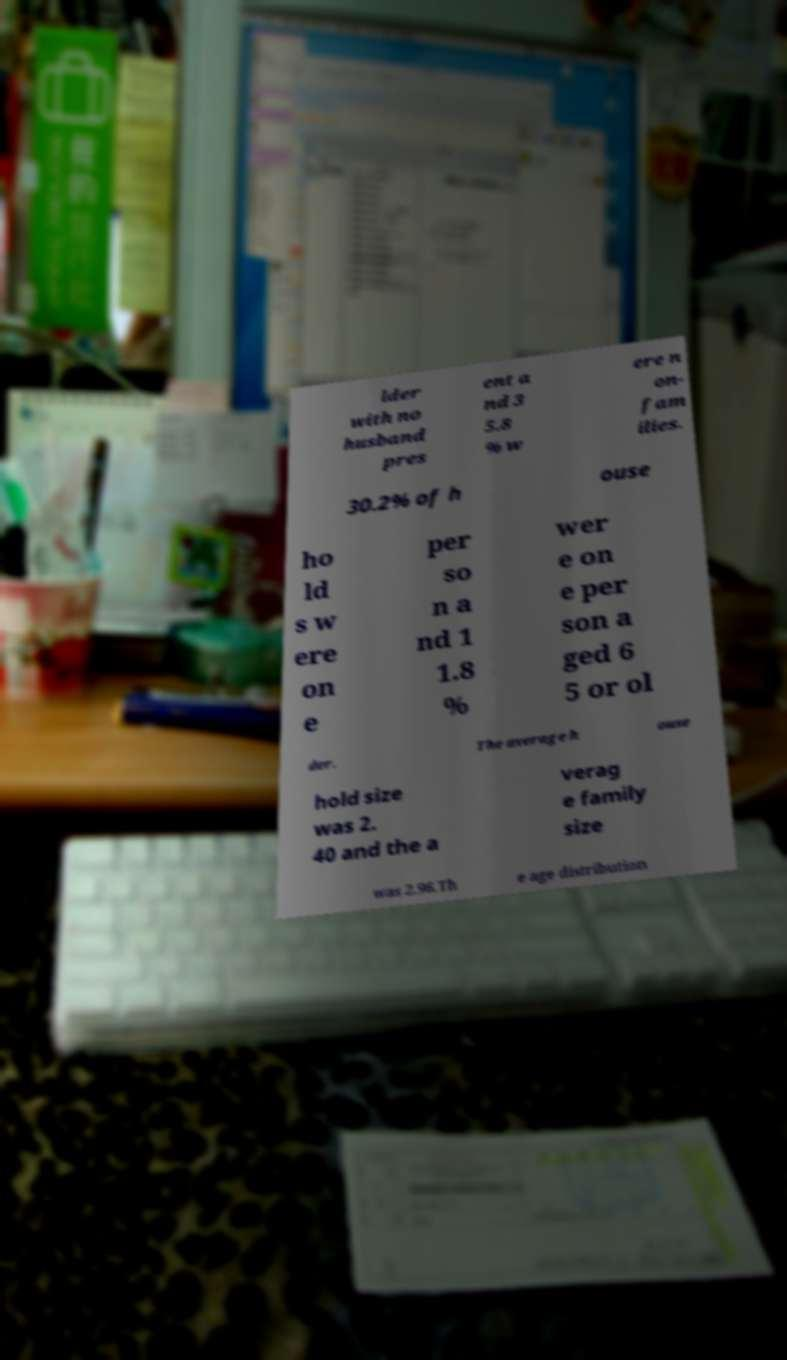What messages or text are displayed in this image? I need them in a readable, typed format. lder with no husband pres ent a nd 3 5.8 % w ere n on- fam ilies. 30.2% of h ouse ho ld s w ere on e per so n a nd 1 1.8 % wer e on e per son a ged 6 5 or ol der. The average h ouse hold size was 2. 40 and the a verag e family size was 2.96.Th e age distribution 